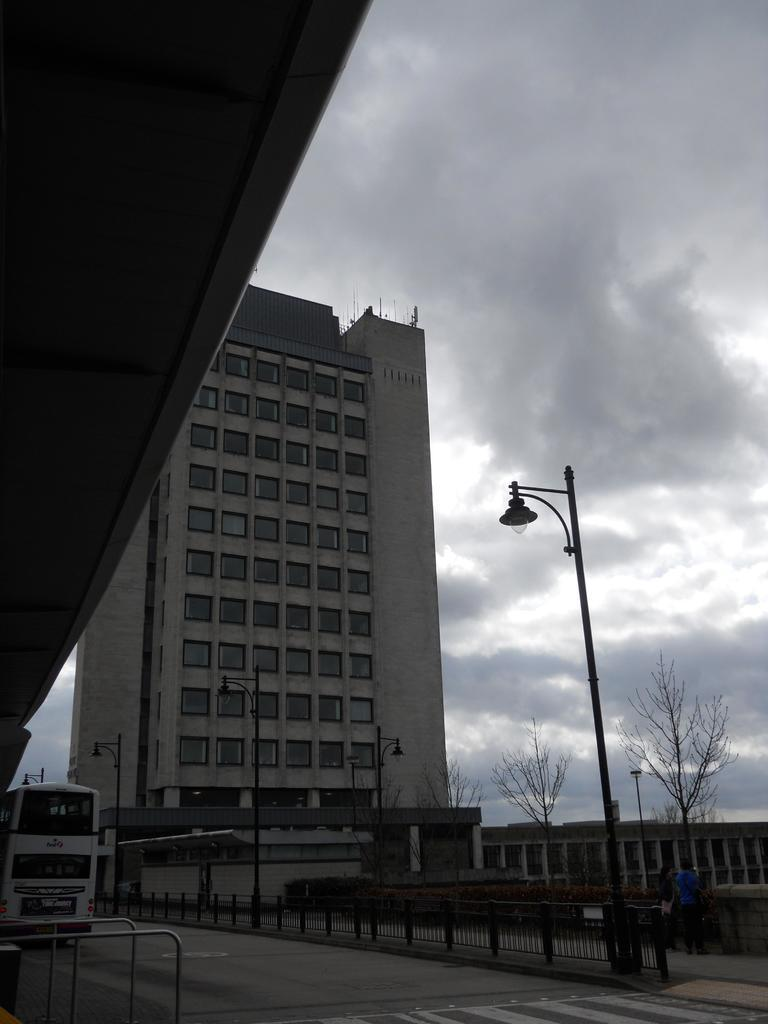What is the main subject in the image? There is a vehicle in the image. What else can be seen in the image besides the vehicle? There are people on the ground in the image. What can be seen in the background of the image? There is a building, poles with lights, trees, and the sky visible in the background of the image. What type of vegetable is being harvested by the people in the image? There are no people harvesting vegetables in the image; they are simply standing on the ground. 